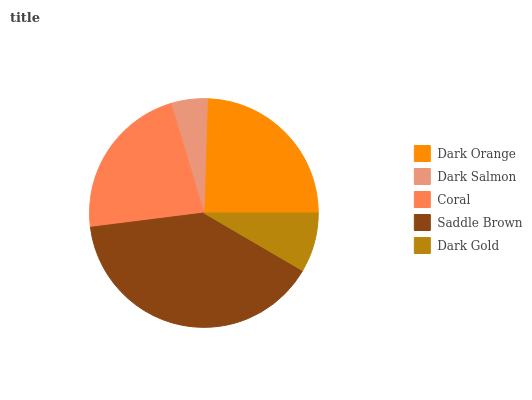Is Dark Salmon the minimum?
Answer yes or no. Yes. Is Saddle Brown the maximum?
Answer yes or no. Yes. Is Coral the minimum?
Answer yes or no. No. Is Coral the maximum?
Answer yes or no. No. Is Coral greater than Dark Salmon?
Answer yes or no. Yes. Is Dark Salmon less than Coral?
Answer yes or no. Yes. Is Dark Salmon greater than Coral?
Answer yes or no. No. Is Coral less than Dark Salmon?
Answer yes or no. No. Is Coral the high median?
Answer yes or no. Yes. Is Coral the low median?
Answer yes or no. Yes. Is Dark Orange the high median?
Answer yes or no. No. Is Dark Orange the low median?
Answer yes or no. No. 